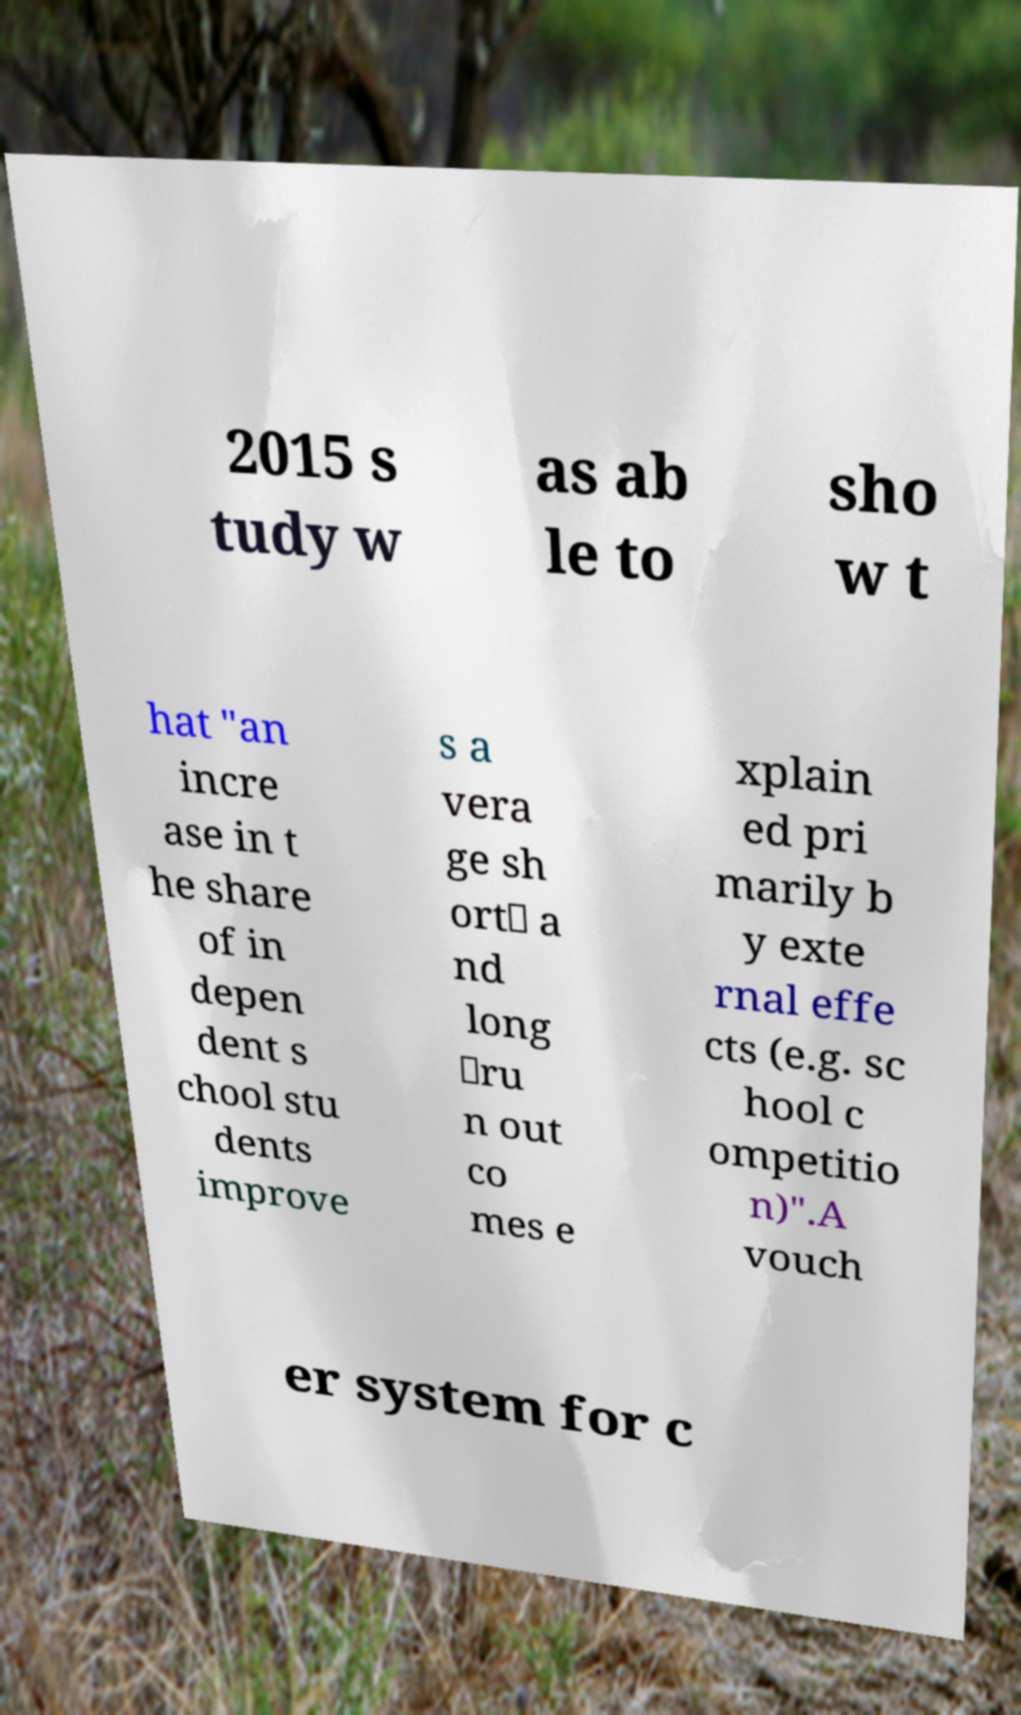There's text embedded in this image that I need extracted. Can you transcribe it verbatim? 2015 s tudy w as ab le to sho w t hat "an incre ase in t he share of in depen dent s chool stu dents improve s a vera ge sh ort‐ a nd long ‐ru n out co mes e xplain ed pri marily b y exte rnal effe cts (e.g. sc hool c ompetitio n)".A vouch er system for c 